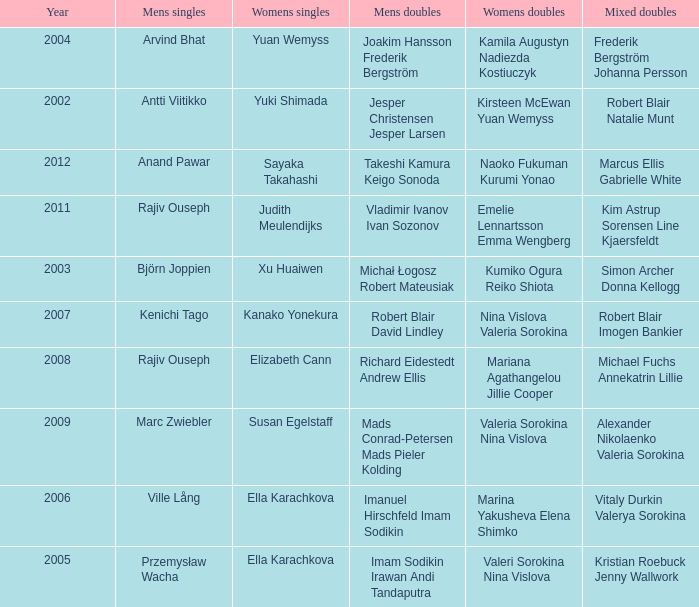What are the womens singles of naoko fukuman kurumi yonao? Sayaka Takahashi. 